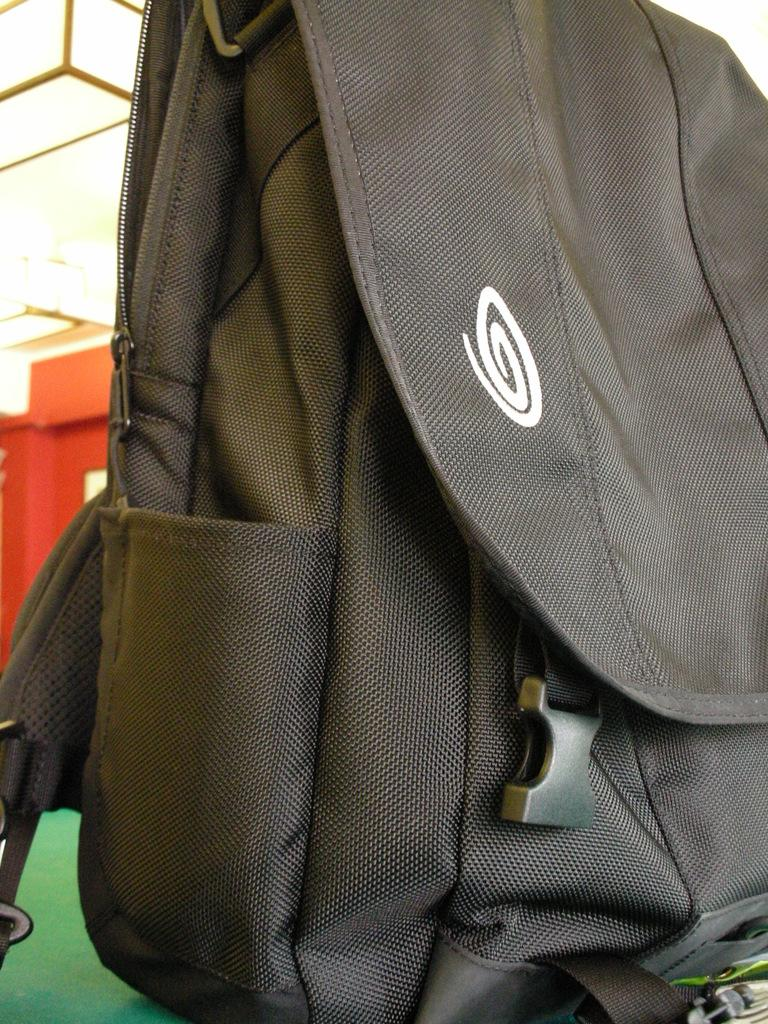What is the color of the bag in the image? The bag in the image is black. What type of texture does the winter season have in the image? There is no reference to winter or any textures in the image, as it only features a black color bag. 